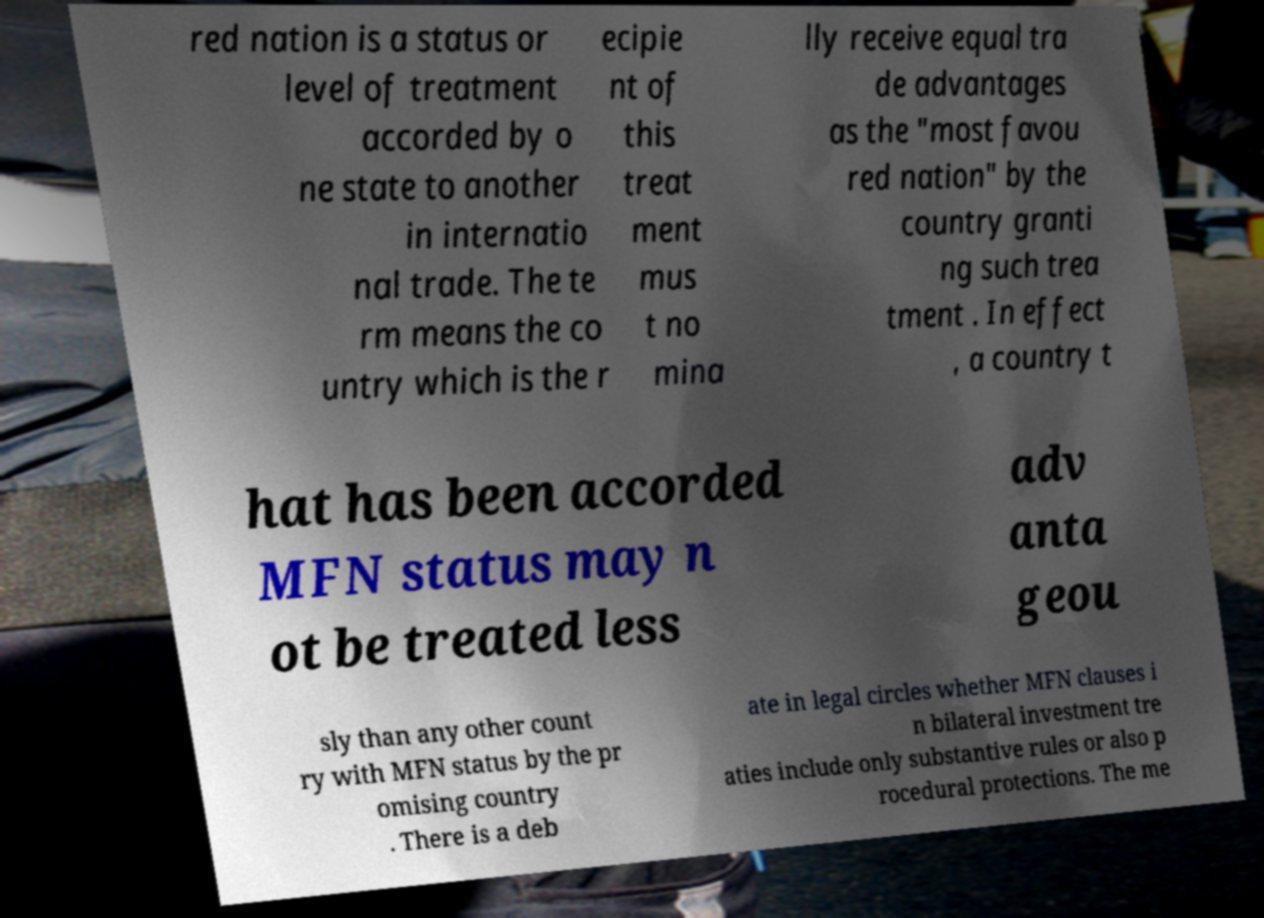For documentation purposes, I need the text within this image transcribed. Could you provide that? red nation is a status or level of treatment accorded by o ne state to another in internatio nal trade. The te rm means the co untry which is the r ecipie nt of this treat ment mus t no mina lly receive equal tra de advantages as the "most favou red nation" by the country granti ng such trea tment . In effect , a country t hat has been accorded MFN status may n ot be treated less adv anta geou sly than any other count ry with MFN status by the pr omising country . There is a deb ate in legal circles whether MFN clauses i n bilateral investment tre aties include only substantive rules or also p rocedural protections. The me 